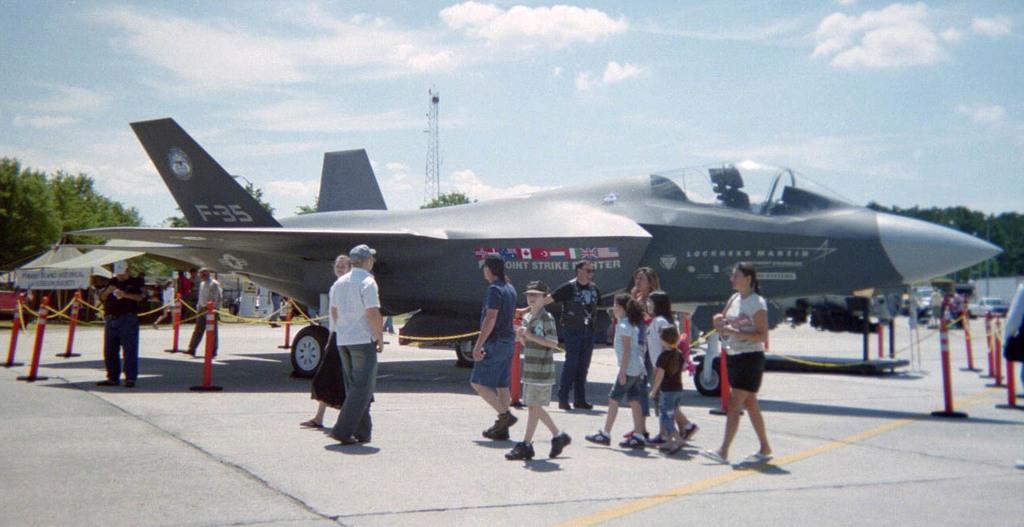Please provide a concise description of this image. In this image there is a plane with poles fence beside that there are so many people walking. 